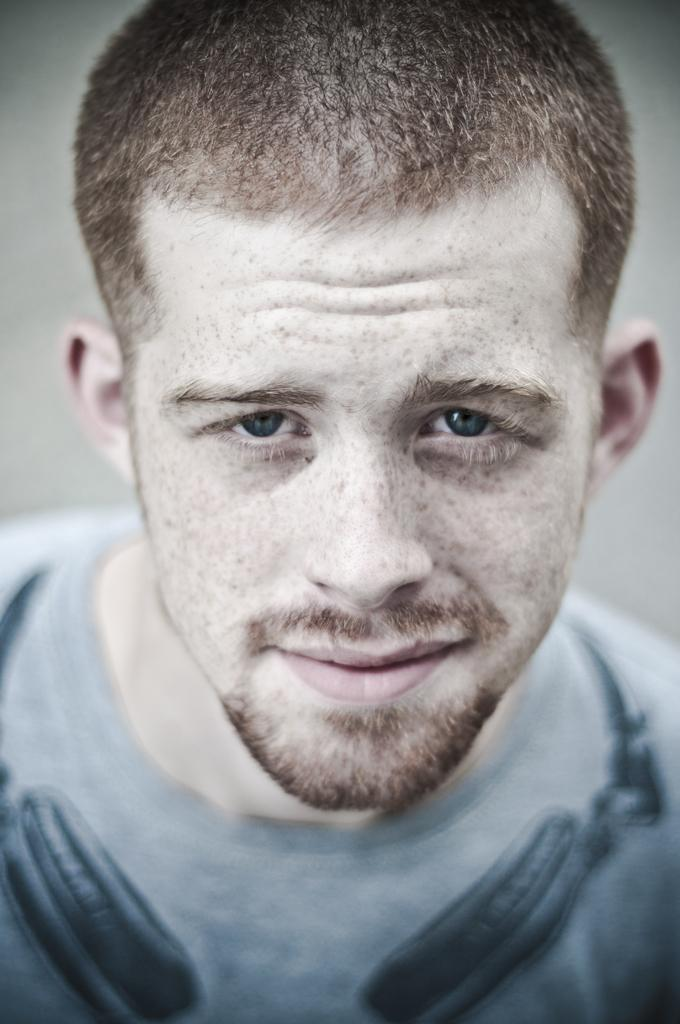What is the main subject of the image? There is a person in the image. What is the person wearing? The person is wearing a t-shirt. What is the person's facial expression? The person is smiling. What is the person holding or wearing around his neck? The person has a headset on his neck. What is the color of the background in the image? The background of the image is gray in color. What type of scarf is the person wearing in the image? There is no scarf present in the image; the person is wearing a t-shirt. Can you tell me what the person's locket contains in the image? There is no locket present in the image; the person has a headset on his neck. 